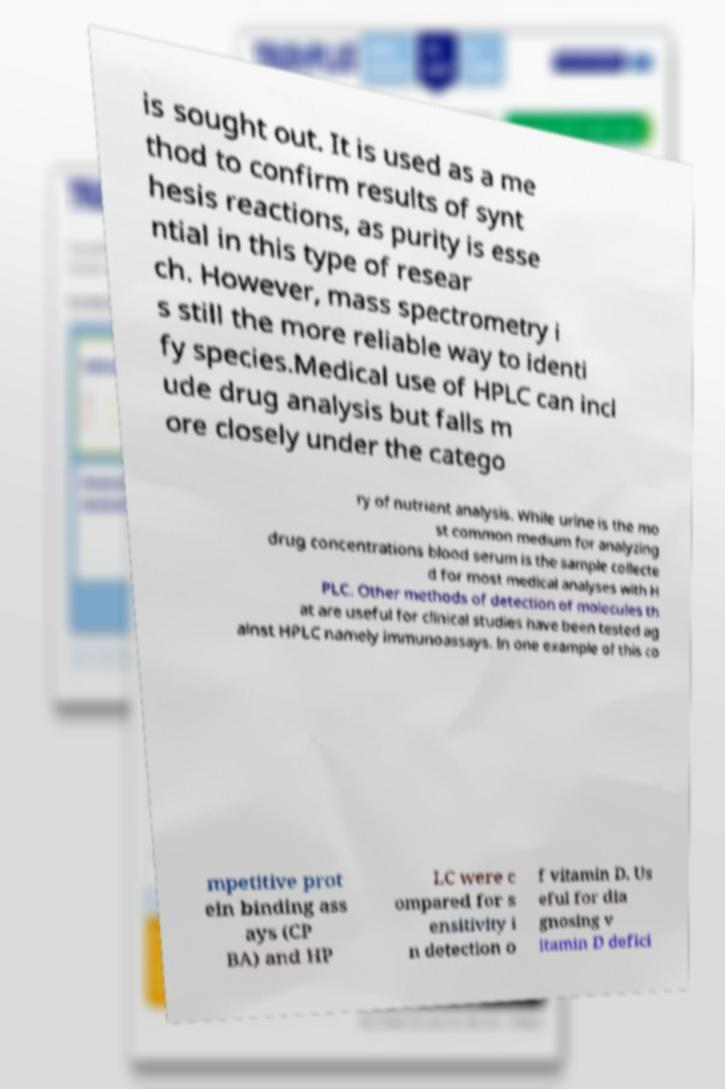What messages or text are displayed in this image? I need them in a readable, typed format. is sought out. It is used as a me thod to confirm results of synt hesis reactions, as purity is esse ntial in this type of resear ch. However, mass spectrometry i s still the more reliable way to identi fy species.Medical use of HPLC can incl ude drug analysis but falls m ore closely under the catego ry of nutrient analysis. While urine is the mo st common medium for analyzing drug concentrations blood serum is the sample collecte d for most medical analyses with H PLC. Other methods of detection of molecules th at are useful for clinical studies have been tested ag ainst HPLC namely immunoassays. In one example of this co mpetitive prot ein binding ass ays (CP BA) and HP LC were c ompared for s ensitivity i n detection o f vitamin D. Us eful for dia gnosing v itamin D defici 